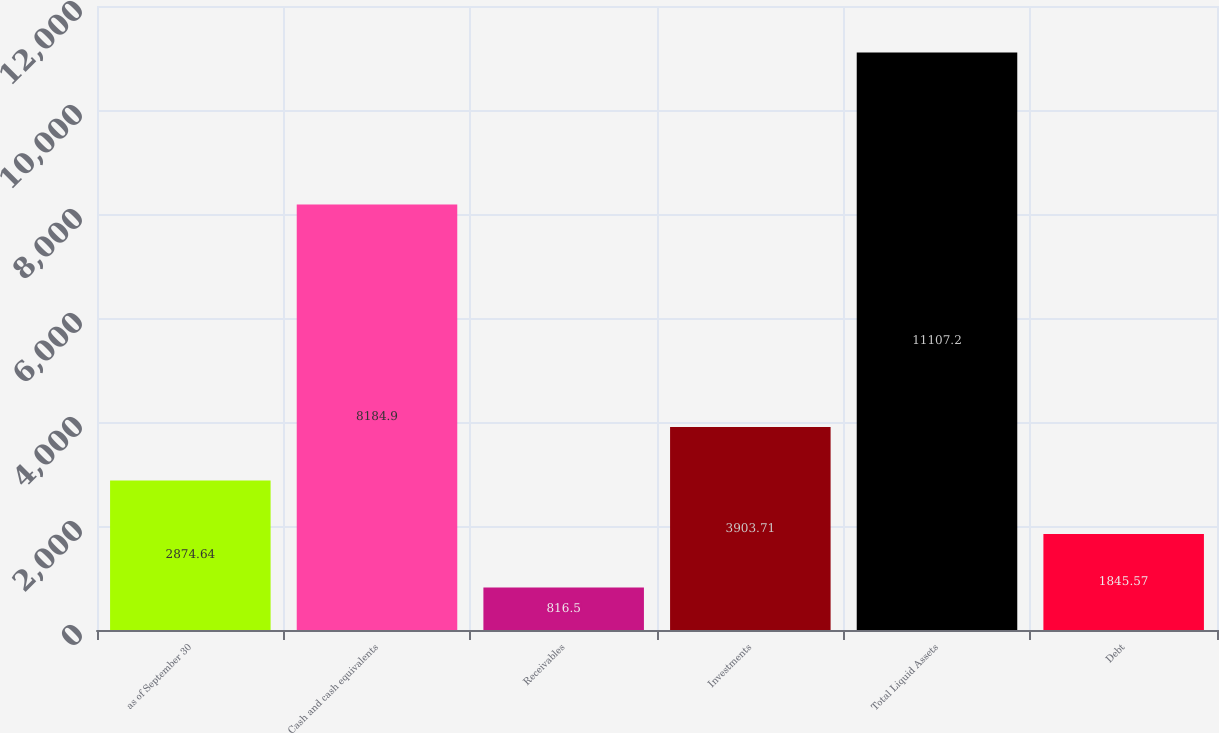Convert chart to OTSL. <chart><loc_0><loc_0><loc_500><loc_500><bar_chart><fcel>as of September 30<fcel>Cash and cash equivalents<fcel>Receivables<fcel>Investments<fcel>Total Liquid Assets<fcel>Debt<nl><fcel>2874.64<fcel>8184.9<fcel>816.5<fcel>3903.71<fcel>11107.2<fcel>1845.57<nl></chart> 